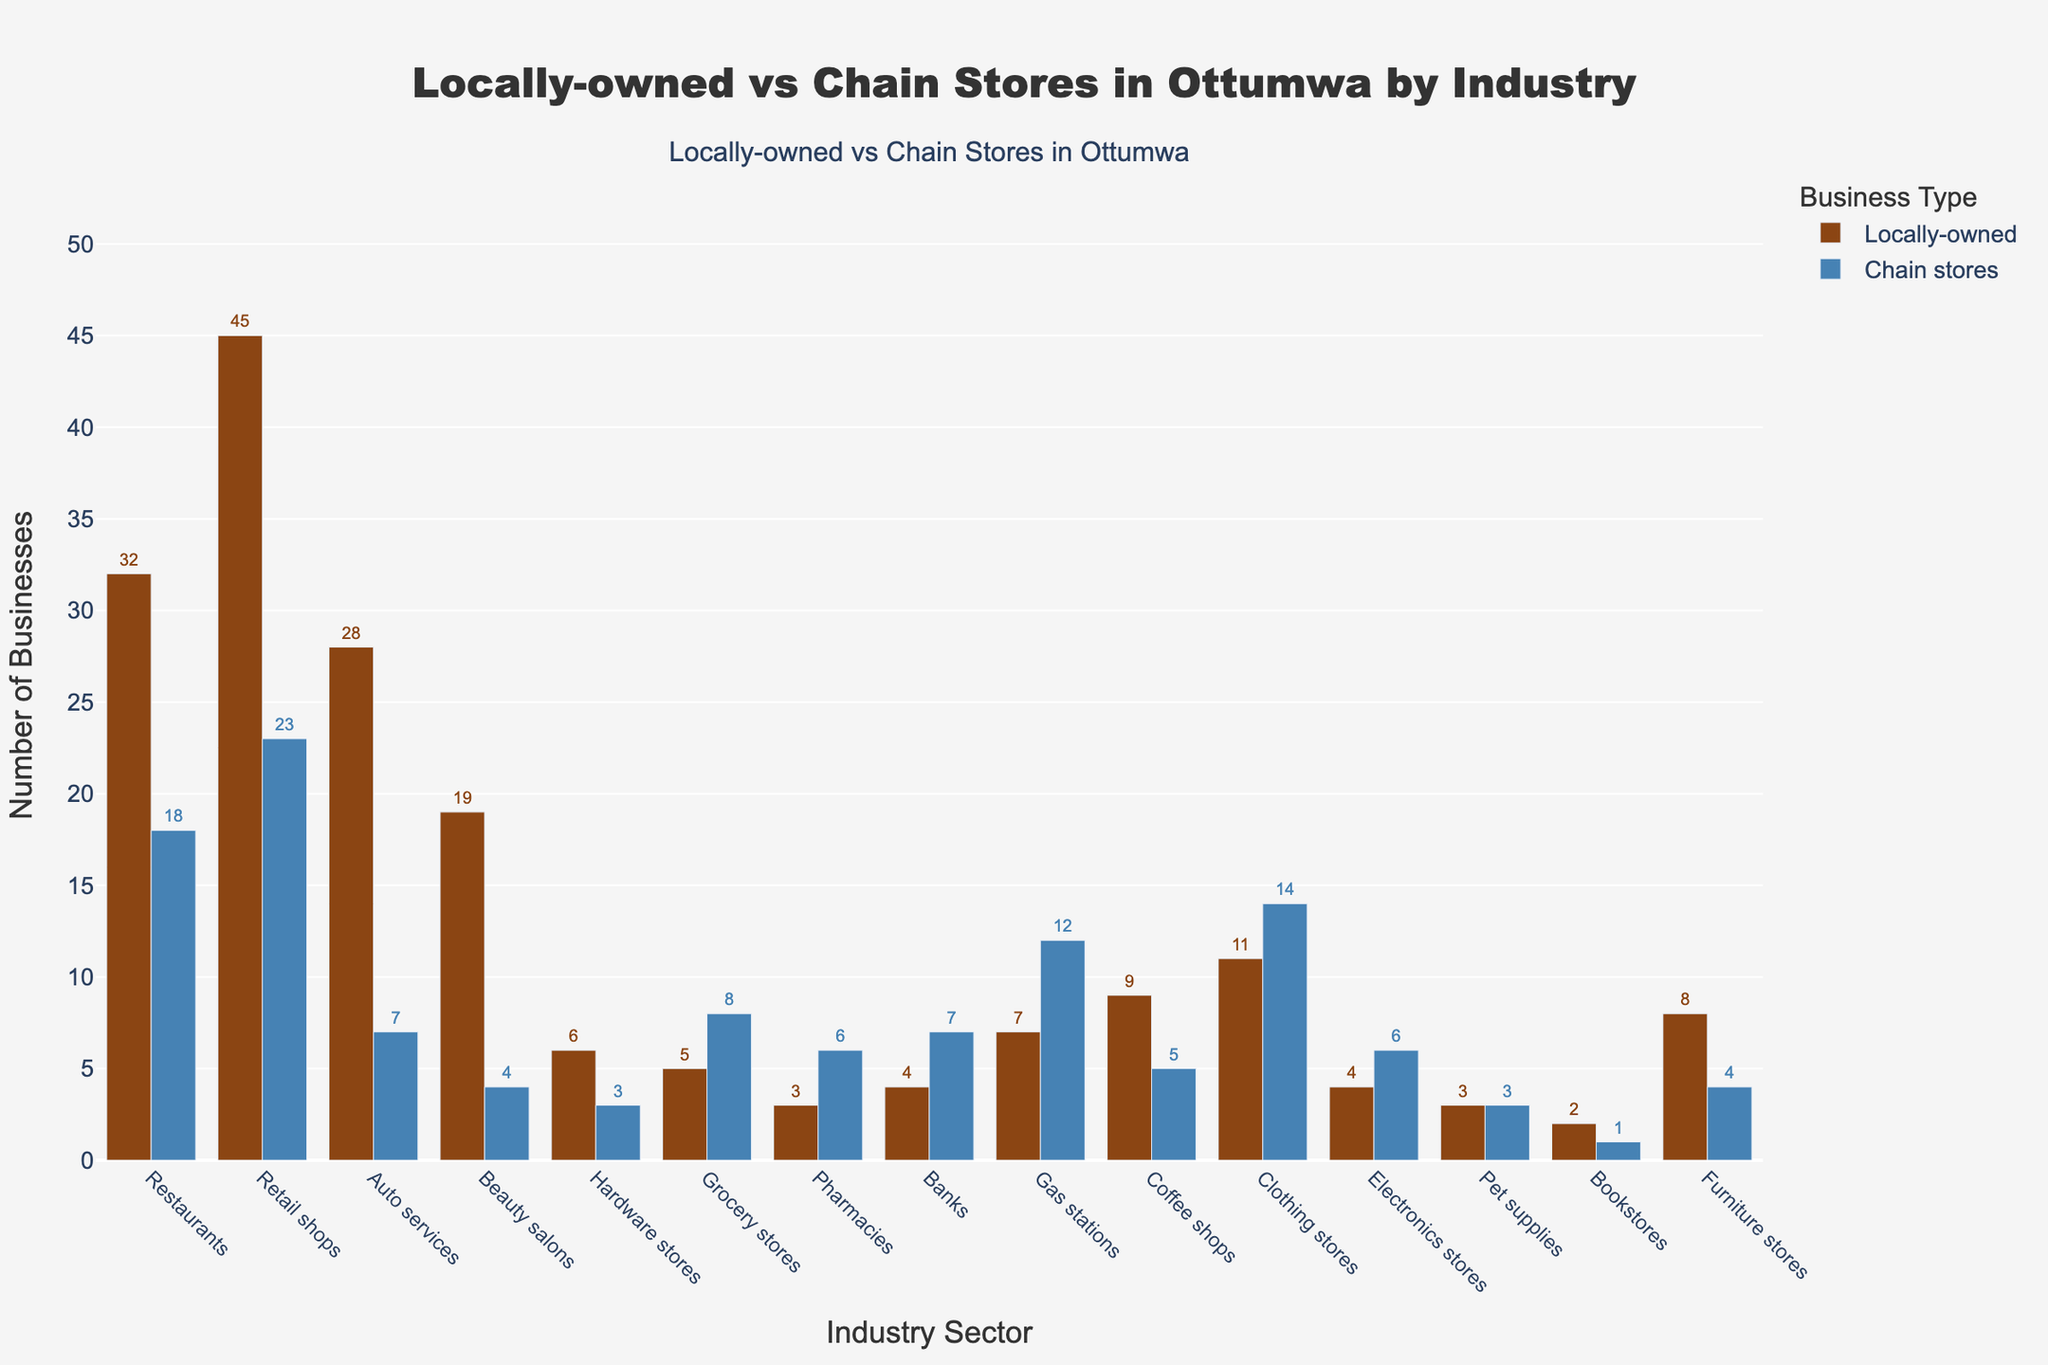Which industry has the highest number of locally-owned businesses? The restaurant industry has 32 locally-owned businesses, which is the highest number among all industries depicted in the figure.
Answer: Restaurants Which industry sector has more chain stores than locally-owned businesses? The grocery stores sector has 8 chain stores and only 5 locally-owned businesses, meaning more chain stores than locally-owned businesses.
Answer: Grocery stores What is the total number of locally-owned restaurants and beauty salons combined? The number of locally-owned restaurants is 32, and beauty salons is 19. Adding these numbers gives 32 + 19 = 51.
Answer: 51 What is the difference in the number of locally-owned and chain auto services? The number of locally-owned auto services is 28, and chain auto services is 7. The difference is 28 - 7 = 21.
Answer: 21 Which industry has an equal number of locally-owned businesses and chain stores? The pet supplies industry has 3 locally-owned businesses and 3 chain stores, so they are equal.
Answer: Pet supplies Is the height of the locally-owned bars generally taller or shorter than the chain store bars? Generally, the height of the locally-owned bars is taller than the chain store bars, as more locally-owned businesses surpass chain store numbers in most industries.
Answer: Taller How many more locally-owned retail shops are there compared to chain retail shops? Locally-owned retail shops are 45, and chain retail shops are 23. The difference is 45 - 23 = 22.
Answer: 22 In which industry sector does the number of chain stores exceed 10? The gas stations industry has 12 chain stores, which meets the criteria of exceeding 10.
Answer: Gas stations What is the combined number of chain stores in the clothing and electronics store industries? Chain stores in the clothing industry are 14, and in electronics, they are 6. Combined, this makes 14 + 6 = 20.
Answer: 20 Which industry has the smallest number of locally-owned businesses and what is this number? The bookstore industry has the smallest number of locally-owned businesses with only 2.
Answer: Bookstores 